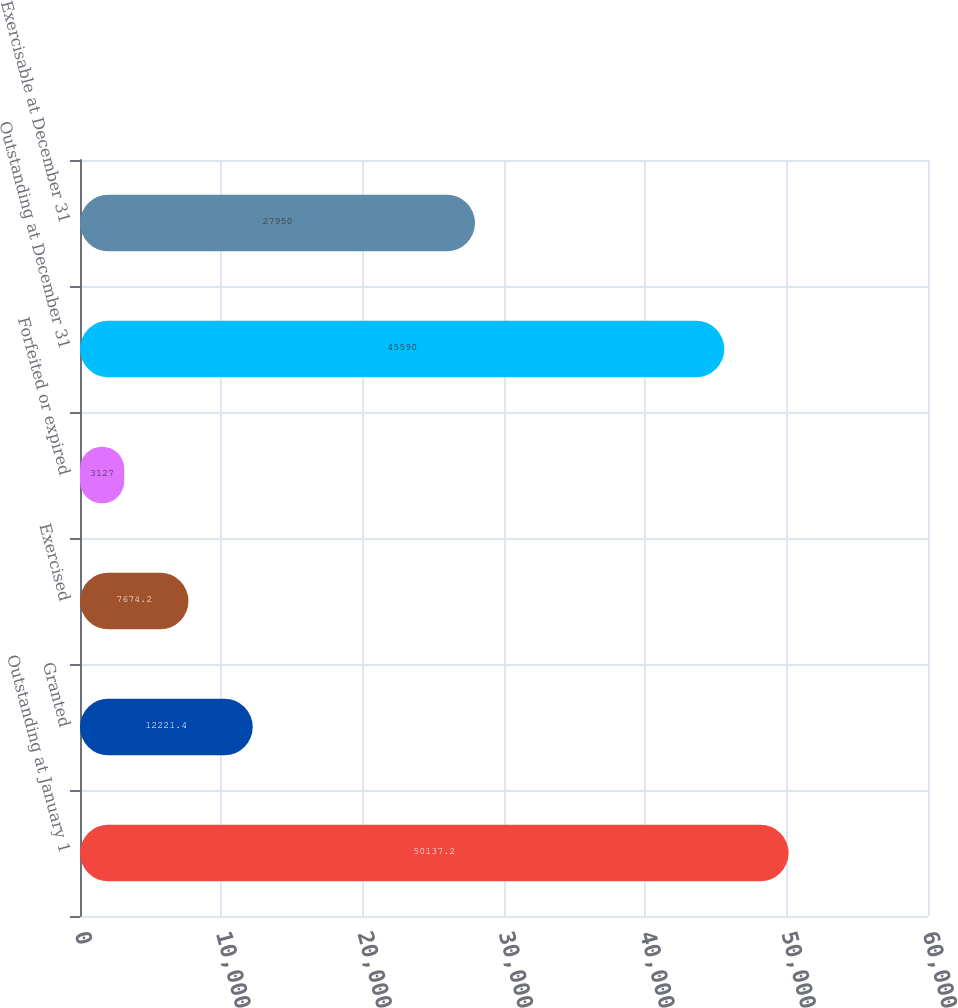Convert chart. <chart><loc_0><loc_0><loc_500><loc_500><bar_chart><fcel>Outstanding at January 1<fcel>Granted<fcel>Exercised<fcel>Forfeited or expired<fcel>Outstanding at December 31<fcel>Exercisable at December 31<nl><fcel>50137.2<fcel>12221.4<fcel>7674.2<fcel>3127<fcel>45590<fcel>27950<nl></chart> 